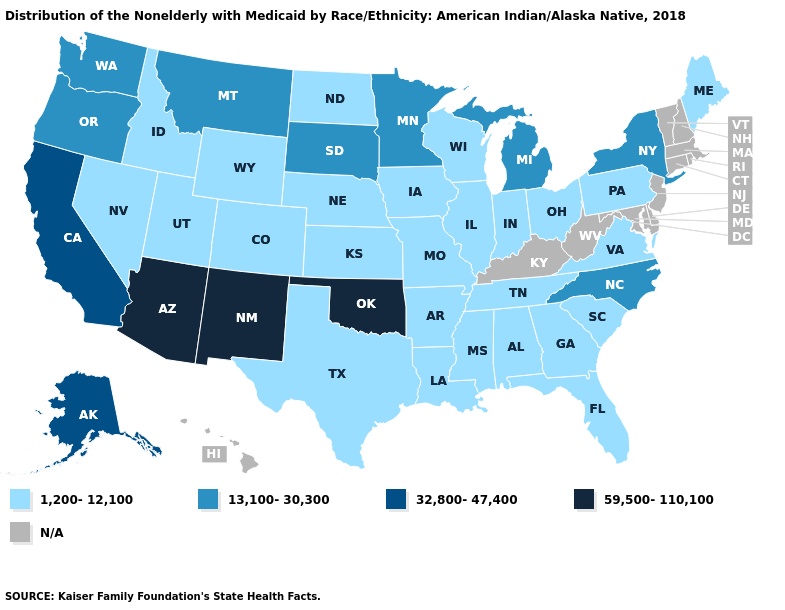What is the highest value in the West ?
Write a very short answer. 59,500-110,100. Name the states that have a value in the range 1,200-12,100?
Give a very brief answer. Alabama, Arkansas, Colorado, Florida, Georgia, Idaho, Illinois, Indiana, Iowa, Kansas, Louisiana, Maine, Mississippi, Missouri, Nebraska, Nevada, North Dakota, Ohio, Pennsylvania, South Carolina, Tennessee, Texas, Utah, Virginia, Wisconsin, Wyoming. Among the states that border Nevada , which have the lowest value?
Write a very short answer. Idaho, Utah. Name the states that have a value in the range 32,800-47,400?
Keep it brief. Alaska, California. Which states have the lowest value in the USA?
Be succinct. Alabama, Arkansas, Colorado, Florida, Georgia, Idaho, Illinois, Indiana, Iowa, Kansas, Louisiana, Maine, Mississippi, Missouri, Nebraska, Nevada, North Dakota, Ohio, Pennsylvania, South Carolina, Tennessee, Texas, Utah, Virginia, Wisconsin, Wyoming. What is the value of West Virginia?
Give a very brief answer. N/A. How many symbols are there in the legend?
Concise answer only. 5. Name the states that have a value in the range 1,200-12,100?
Answer briefly. Alabama, Arkansas, Colorado, Florida, Georgia, Idaho, Illinois, Indiana, Iowa, Kansas, Louisiana, Maine, Mississippi, Missouri, Nebraska, Nevada, North Dakota, Ohio, Pennsylvania, South Carolina, Tennessee, Texas, Utah, Virginia, Wisconsin, Wyoming. Name the states that have a value in the range 13,100-30,300?
Give a very brief answer. Michigan, Minnesota, Montana, New York, North Carolina, Oregon, South Dakota, Washington. What is the value of Georgia?
Give a very brief answer. 1,200-12,100. Does the first symbol in the legend represent the smallest category?
Concise answer only. Yes. Name the states that have a value in the range 32,800-47,400?
Concise answer only. Alaska, California. What is the lowest value in the MidWest?
Write a very short answer. 1,200-12,100. 